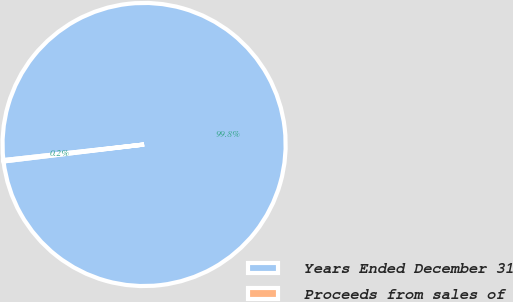Convert chart. <chart><loc_0><loc_0><loc_500><loc_500><pie_chart><fcel>Years Ended December 31<fcel>Proceeds from sales of<nl><fcel>99.85%<fcel>0.15%<nl></chart> 